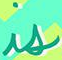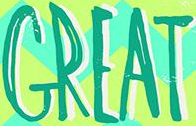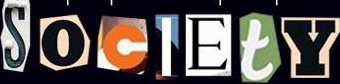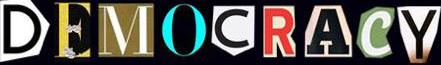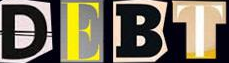What text appears in these images from left to right, separated by a semicolon? is; GREAT; SocIEtY; DEMOCRACY; DEBT 